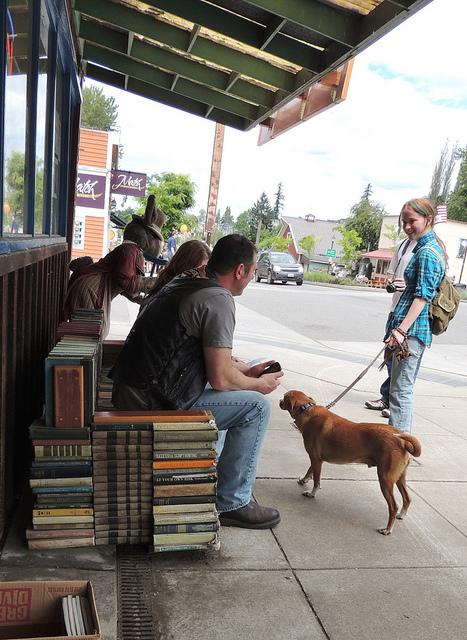From which room could items used to make this chair originate?

Choices:
A) library
B) kitchen
C) dining room
D) sewing room library 